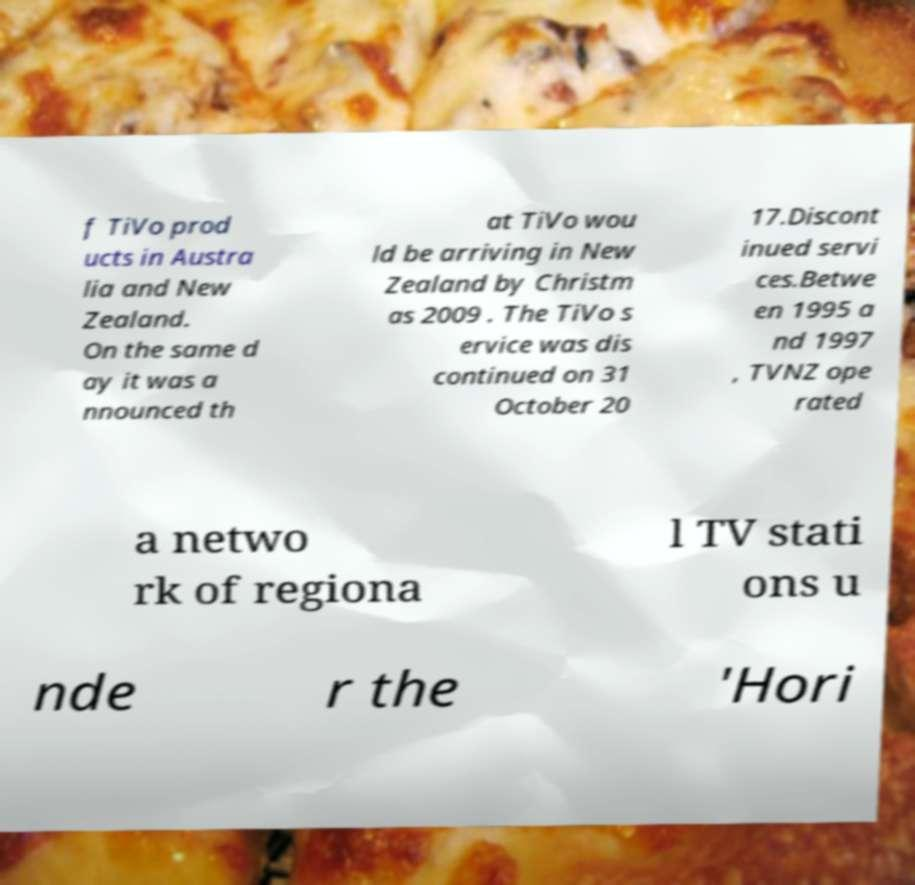Can you accurately transcribe the text from the provided image for me? f TiVo prod ucts in Austra lia and New Zealand. On the same d ay it was a nnounced th at TiVo wou ld be arriving in New Zealand by Christm as 2009 . The TiVo s ervice was dis continued on 31 October 20 17.Discont inued servi ces.Betwe en 1995 a nd 1997 , TVNZ ope rated a netwo rk of regiona l TV stati ons u nde r the 'Hori 